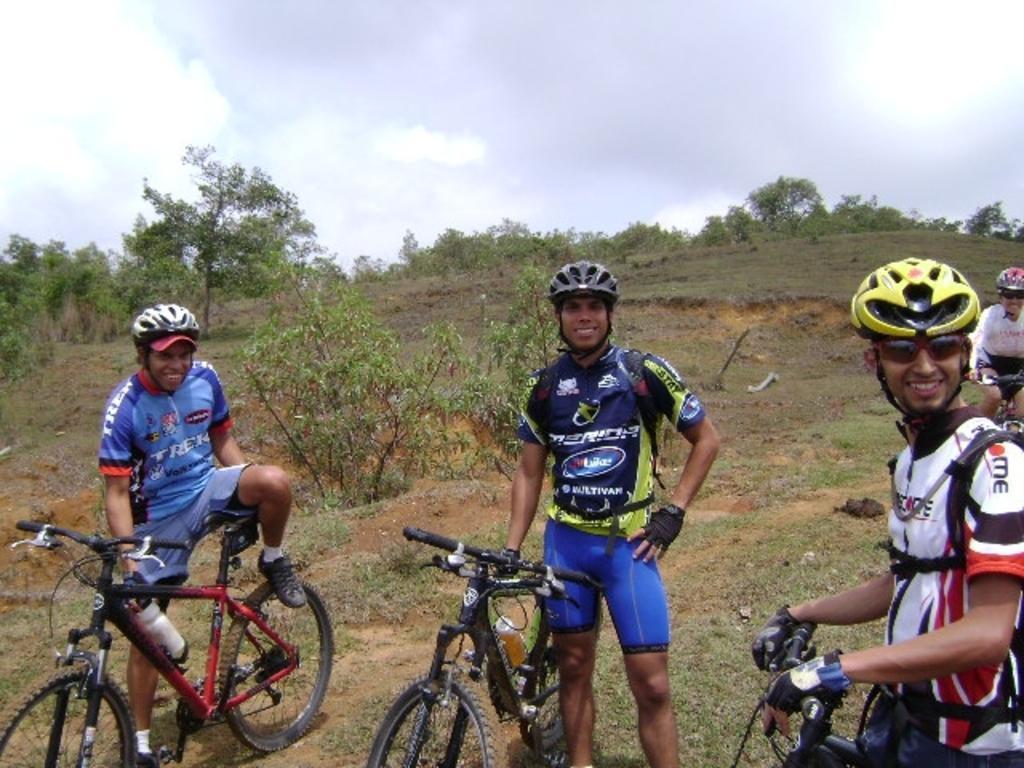Can you describe this image briefly? In this picture in the front there are persons standing and sitting on bicycle. In the background there are trees and the sky is cloudy and the persons are smiling. 